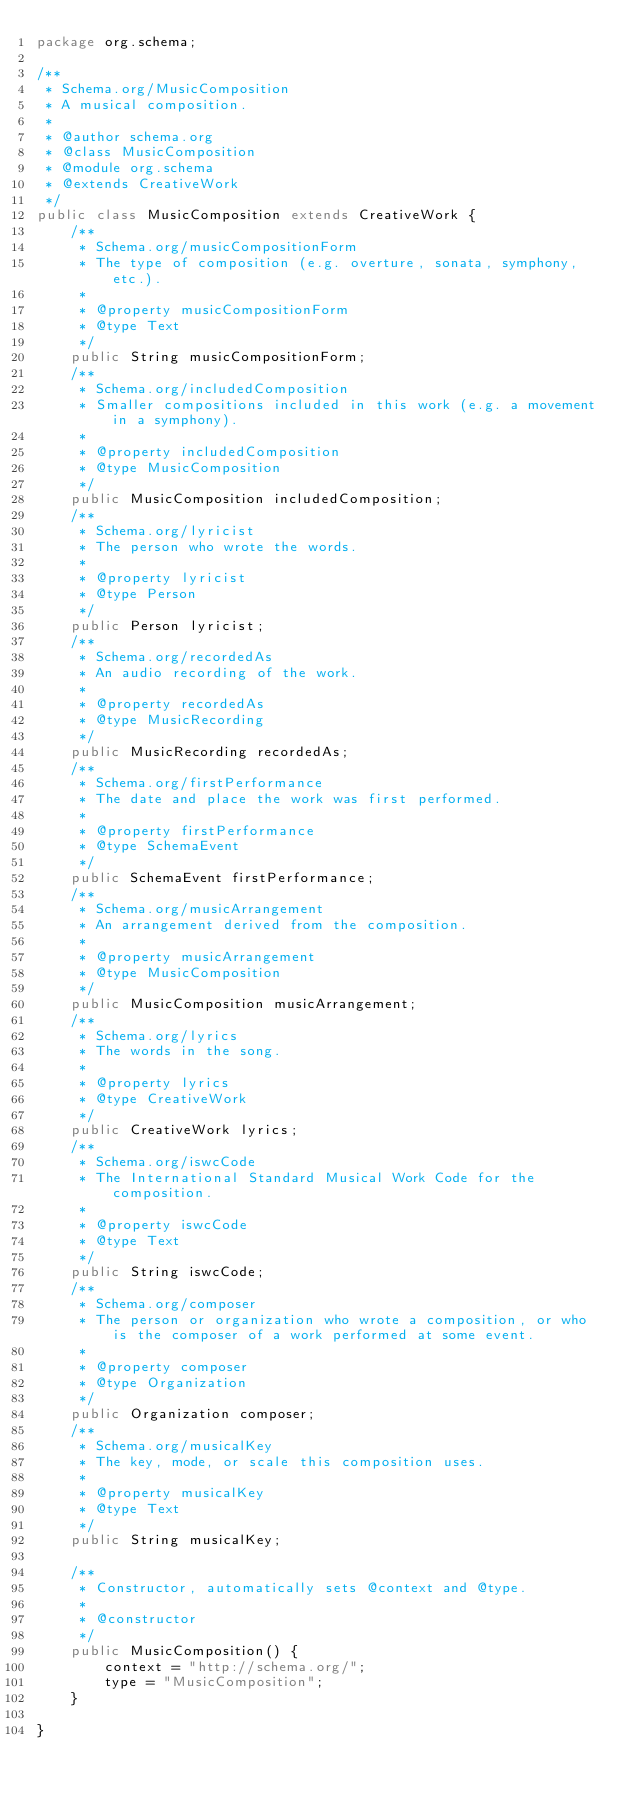<code> <loc_0><loc_0><loc_500><loc_500><_Java_>package org.schema;

/**
 * Schema.org/MusicComposition
 * A musical composition.
 *
 * @author schema.org
 * @class MusicComposition
 * @module org.schema
 * @extends CreativeWork
 */
public class MusicComposition extends CreativeWork {
	/**
	 * Schema.org/musicCompositionForm
	 * The type of composition (e.g. overture, sonata, symphony, etc.).
	 *
	 * @property musicCompositionForm
	 * @type Text
	 */
	public String musicCompositionForm;
	/**
	 * Schema.org/includedComposition
	 * Smaller compositions included in this work (e.g. a movement in a symphony).
	 *
	 * @property includedComposition
	 * @type MusicComposition
	 */
	public MusicComposition includedComposition;
	/**
	 * Schema.org/lyricist
	 * The person who wrote the words.
	 *
	 * @property lyricist
	 * @type Person
	 */
	public Person lyricist;
	/**
	 * Schema.org/recordedAs
	 * An audio recording of the work.
	 *
	 * @property recordedAs
	 * @type MusicRecording
	 */
	public MusicRecording recordedAs;
	/**
	 * Schema.org/firstPerformance
	 * The date and place the work was first performed.
	 *
	 * @property firstPerformance
	 * @type SchemaEvent
	 */
	public SchemaEvent firstPerformance;
	/**
	 * Schema.org/musicArrangement
	 * An arrangement derived from the composition.
	 *
	 * @property musicArrangement
	 * @type MusicComposition
	 */
	public MusicComposition musicArrangement;
	/**
	 * Schema.org/lyrics
	 * The words in the song.
	 *
	 * @property lyrics
	 * @type CreativeWork
	 */
	public CreativeWork lyrics;
	/**
	 * Schema.org/iswcCode
	 * The International Standard Musical Work Code for the composition.
	 *
	 * @property iswcCode
	 * @type Text
	 */
	public String iswcCode;
	/**
	 * Schema.org/composer
	 * The person or organization who wrote a composition, or who is the composer of a work performed at some event.
	 *
	 * @property composer
	 * @type Organization
	 */
	public Organization composer;
	/**
	 * Schema.org/musicalKey
	 * The key, mode, or scale this composition uses.
	 *
	 * @property musicalKey
	 * @type Text
	 */
	public String musicalKey;

	/**
	 * Constructor, automatically sets @context and @type.
	 *
	 * @constructor
	 */
	public MusicComposition() {
		context = "http://schema.org/";
		type = "MusicComposition";
	}

}</code> 